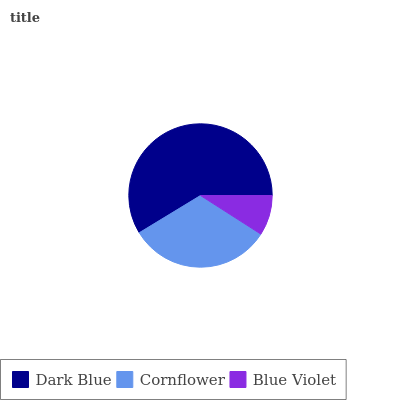Is Blue Violet the minimum?
Answer yes or no. Yes. Is Dark Blue the maximum?
Answer yes or no. Yes. Is Cornflower the minimum?
Answer yes or no. No. Is Cornflower the maximum?
Answer yes or no. No. Is Dark Blue greater than Cornflower?
Answer yes or no. Yes. Is Cornflower less than Dark Blue?
Answer yes or no. Yes. Is Cornflower greater than Dark Blue?
Answer yes or no. No. Is Dark Blue less than Cornflower?
Answer yes or no. No. Is Cornflower the high median?
Answer yes or no. Yes. Is Cornflower the low median?
Answer yes or no. Yes. Is Blue Violet the high median?
Answer yes or no. No. Is Dark Blue the low median?
Answer yes or no. No. 